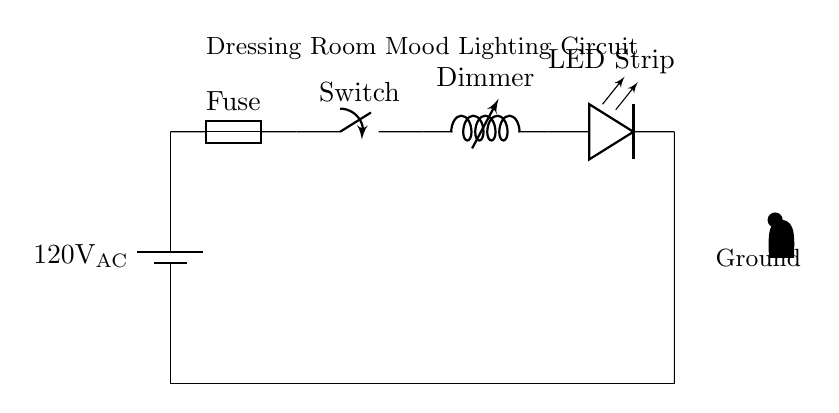What is the power source voltage in this circuit? The circuit provides a power source of 120 volts alternating current, as indicated by the battery symbol labeled with "120V AC."
Answer: 120 volts AC What component allows for adjustable brightness in the lighting? The circuit includes a variable inductor, referred to as a dimmer, which provides control over the brightness level of the LED strip, allowing for adjustable mood lighting.
Answer: Dimmer What type of lighting is used in this circuit? The circuit is designed with an LED strip, as indicated by the component labeled "LED Strip," which is known for its energy efficiency and brightness control.
Answer: LED strip How many main components are present in the circuit? The diagram shows six main components: a power source, fuse, switch, dimmer, LED, and ground connection, which are essential for the functioning of the circuit.
Answer: Six What is the purpose of the fuse in this circuit? The fuse is a safety component that protects the circuit from excessive current, potentially preventing overheating and damage to the other components, which is critical in low-power appliance applications.
Answer: Safety protection What does the presence of the ground connection indicate? The ground connection provides a reference point for the circuit's voltage levels and enhances safety by ensuring that excess current has a path to dissipate, preventing electrical shock or damage.
Answer: Circuit safety 